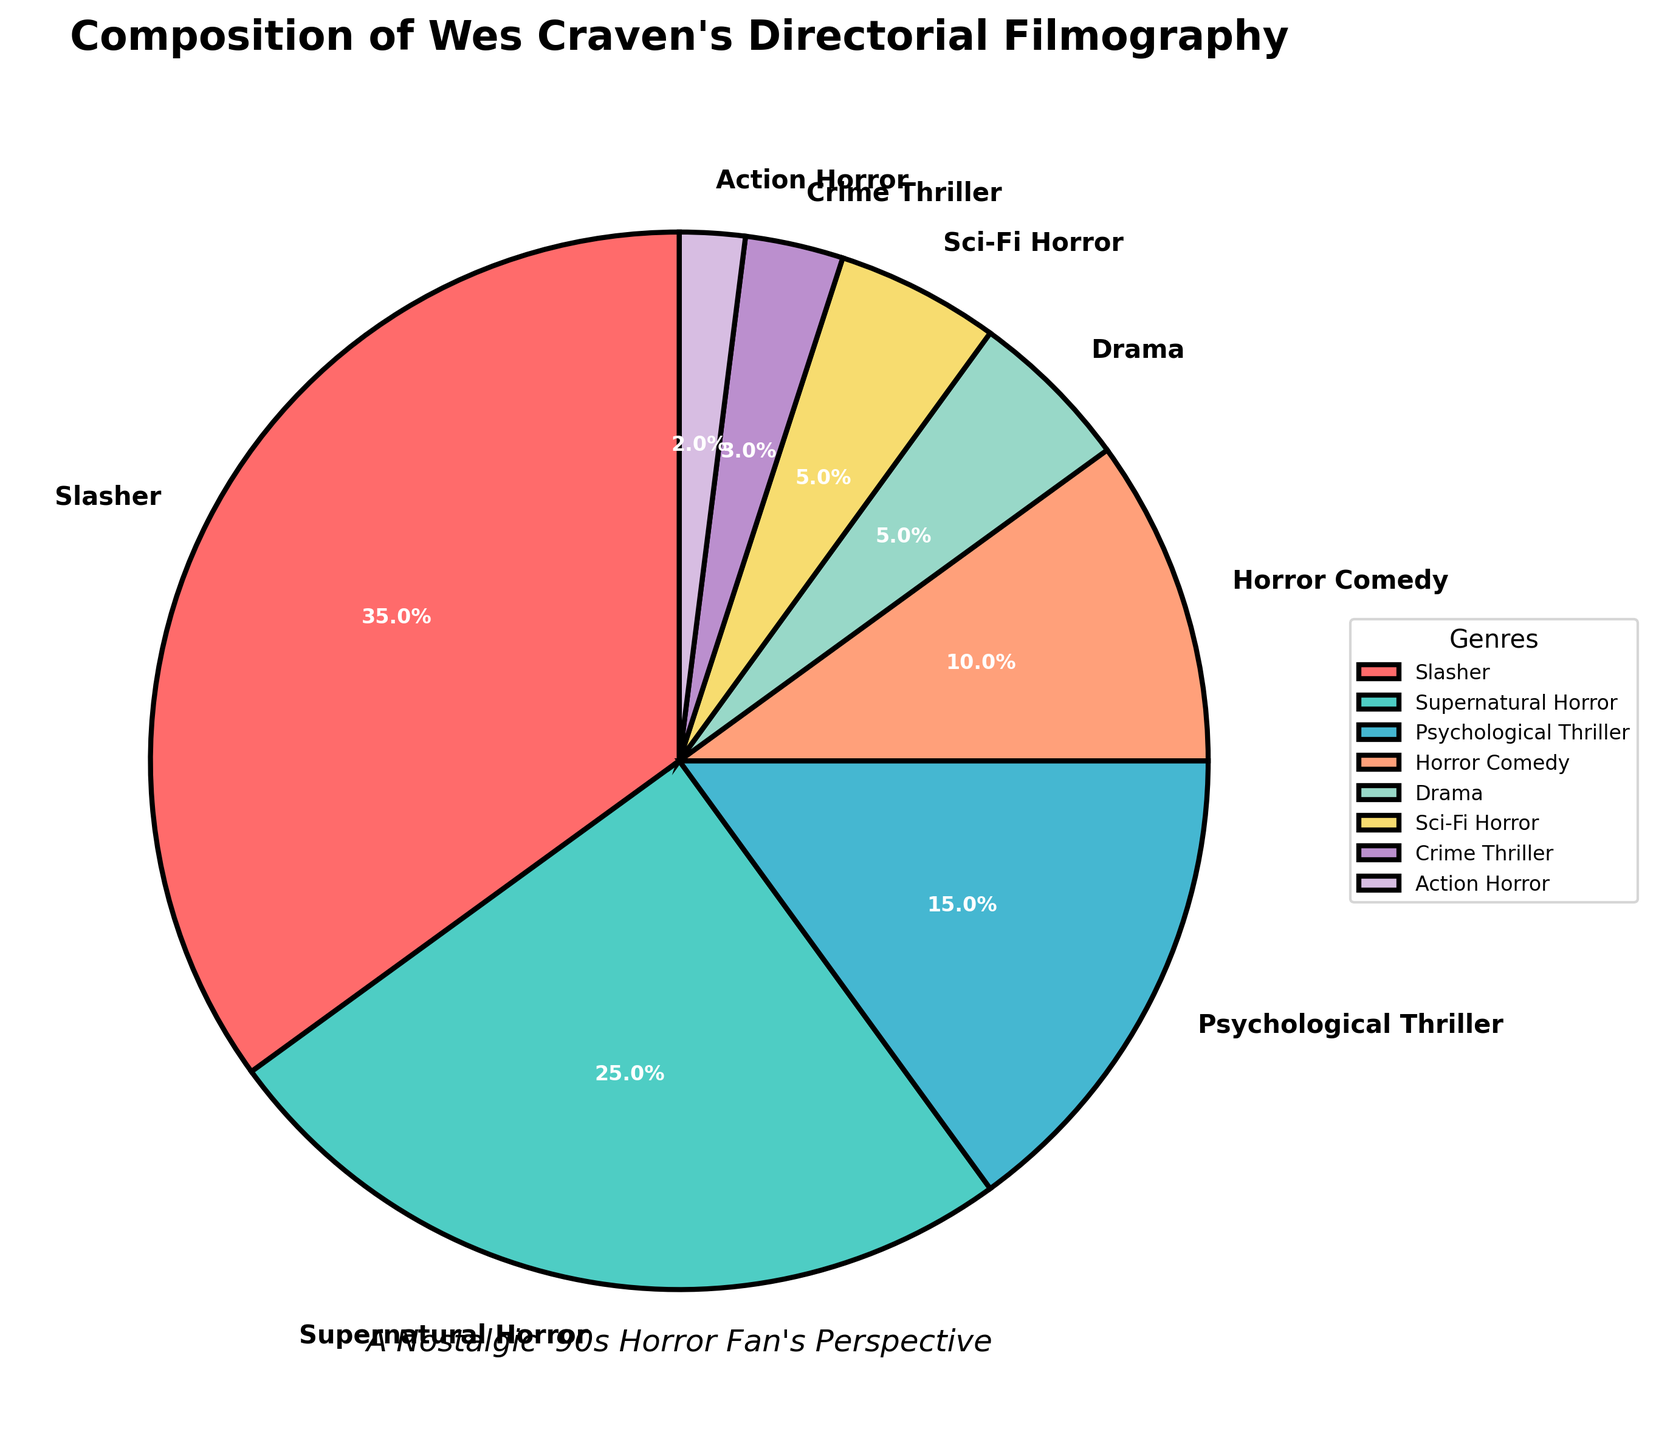What is the combined percentage of 'Crime Thriller' and 'Action Horror' genres in Wes Craven's filmography? The 'Crime Thriller' genre accounts for 3%, and the 'Action Horror' genre accounts for 2%. Their combined percentage is 3% + 2% = 5%.
Answer: 5% Which genre has the highest percentage in Wes Craven's filmography, and what is that percentage? The genre with the highest percentage is identified by the slice covering the largest area. The 'Slasher' genre has the highest percentage, which is 35%.
Answer: Slasher, 35% If you sum the percentages of 'Psychological Thriller' and 'Supernatural Horror', will it be greater than the percentage of 'Slasher'? The percentage of 'Psychological Thriller' is 15% and 'Supernatural Horror' is 25%. Their sum is 15% + 25% = 40%, which is greater than the 'Slasher' genre percentage of 35%.
Answer: Yes Which genre shares the same percentage in Wes Craven's filmography, and what is that percentage? The genres with the same percentage can be identified by comparing their sizes in the pie chart. The 'Drama' and 'Sci-Fi Horror' genres both have a percentage of 5%.
Answer: Drama and Sci-Fi Horror, 5% How much more percentage does 'Slasher' have compared to 'Supernatural Horror'? The 'Slasher' genre has 35%, and the 'Supernatural Horror' genre has 25%. The difference is 35% - 25% = 10%.
Answer: 10% Rank the top three genres by percentage in Wes Craven's filmography. The percentages are sorted in descending order: 'Slasher' (35%), 'Supernatural Horror' (25%), and 'Psychological Thriller' (15%). The top three genres are 'Slasher', 'Supernatural Horror', and 'Psychological Thriller'.
Answer: Slasher, Supernatural Horror, Psychological Thriller Identify the visual attribute used to distinguish different genres in the pie chart. The pie chart uses different colors for each genre to visually distinguish them. This allows viewers to easily identify and differentiate the genres.
Answer: Colors What is the total percentage of all the genres combined in Wes Craven's filmography? The sum of all the genre percentages in a pie chart should equal 100%. Adding each percentage: 35% + 25% + 15% + 10% + 5% + 5% + 3% + 2% = 100%.
Answer: 100% Which genre is represented by the color green in the pie chart? By observing the color coding in the pie chart, the 'Supernatural Horror' genre is represented by the green slice.
Answer: Supernatural Horror How do the combined percentages of 'Horror Comedy' and 'Drama' compare to the percentage of 'Psychological Thriller'? The 'Horror Comedy' genre accounts for 10%, and 'Drama' accounts for 5%. Their combined percentage is 10% + 5% = 15%, which is equal to the 'Psychological Thriller' percentage of 15%.
Answer: Equal 